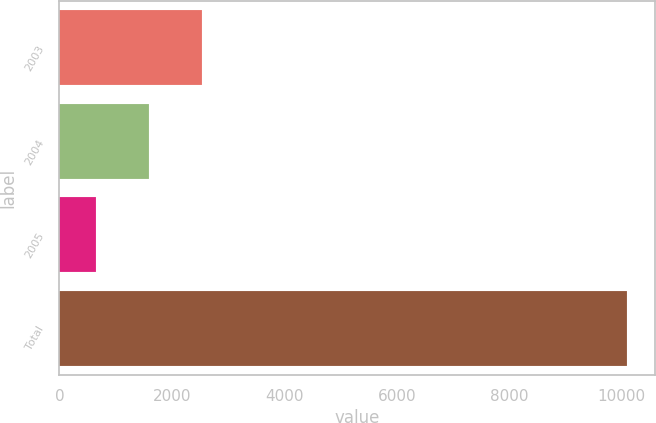<chart> <loc_0><loc_0><loc_500><loc_500><bar_chart><fcel>2003<fcel>2004<fcel>2005<fcel>Total<nl><fcel>2543.6<fcel>1600.8<fcel>658<fcel>10086<nl></chart> 